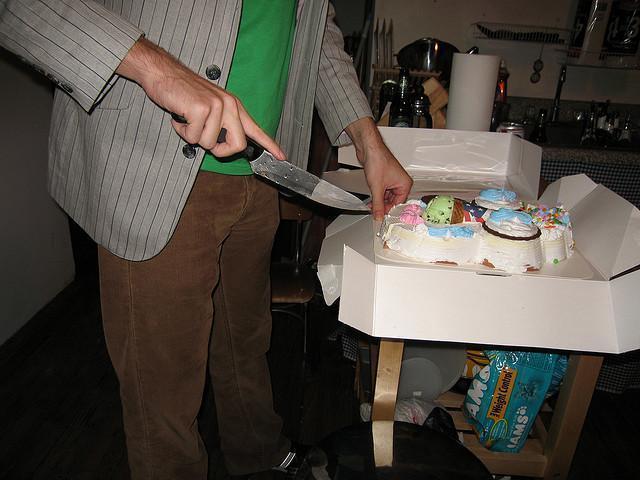What might be a major component of this treat?
Select the accurate response from the four choices given to answer the question.
Options: Carrots, muffins, ice cream, raisins. Ice cream. 